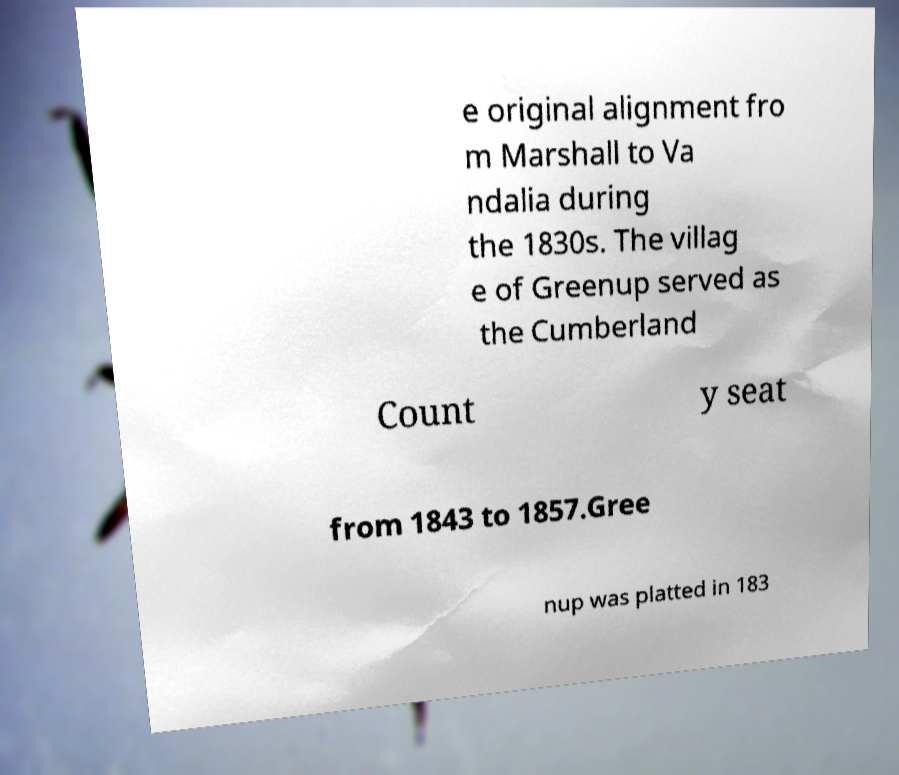What messages or text are displayed in this image? I need them in a readable, typed format. e original alignment fro m Marshall to Va ndalia during the 1830s. The villag e of Greenup served as the Cumberland Count y seat from 1843 to 1857.Gree nup was platted in 183 